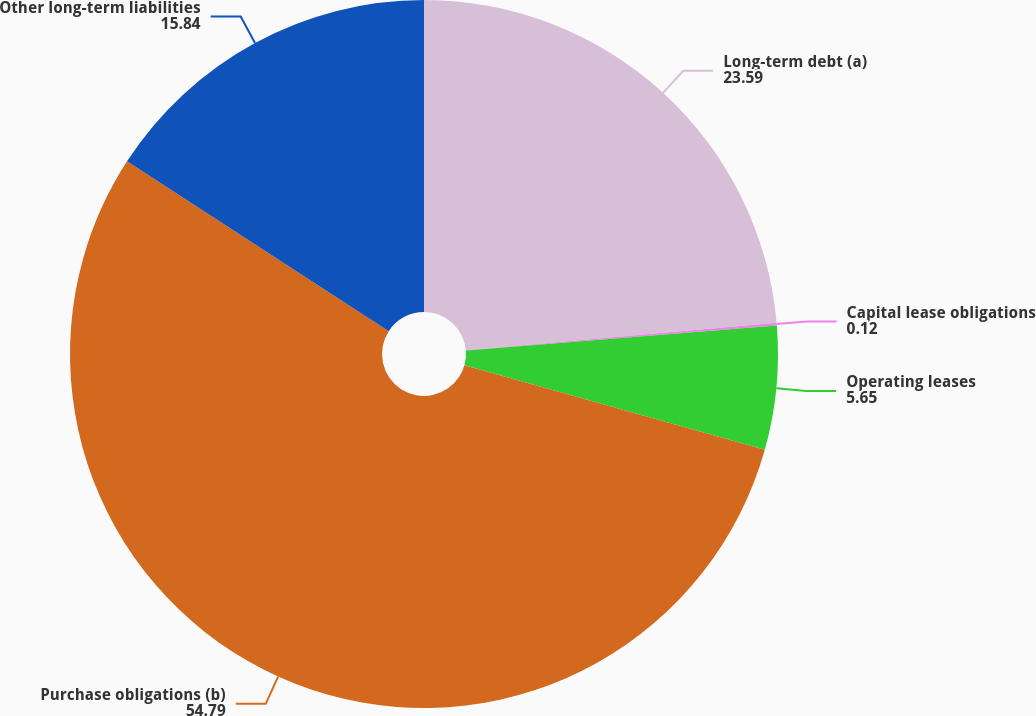<chart> <loc_0><loc_0><loc_500><loc_500><pie_chart><fcel>Long-term debt (a)<fcel>Capital lease obligations<fcel>Operating leases<fcel>Purchase obligations (b)<fcel>Other long-term liabilities<nl><fcel>23.59%<fcel>0.12%<fcel>5.65%<fcel>54.79%<fcel>15.84%<nl></chart> 